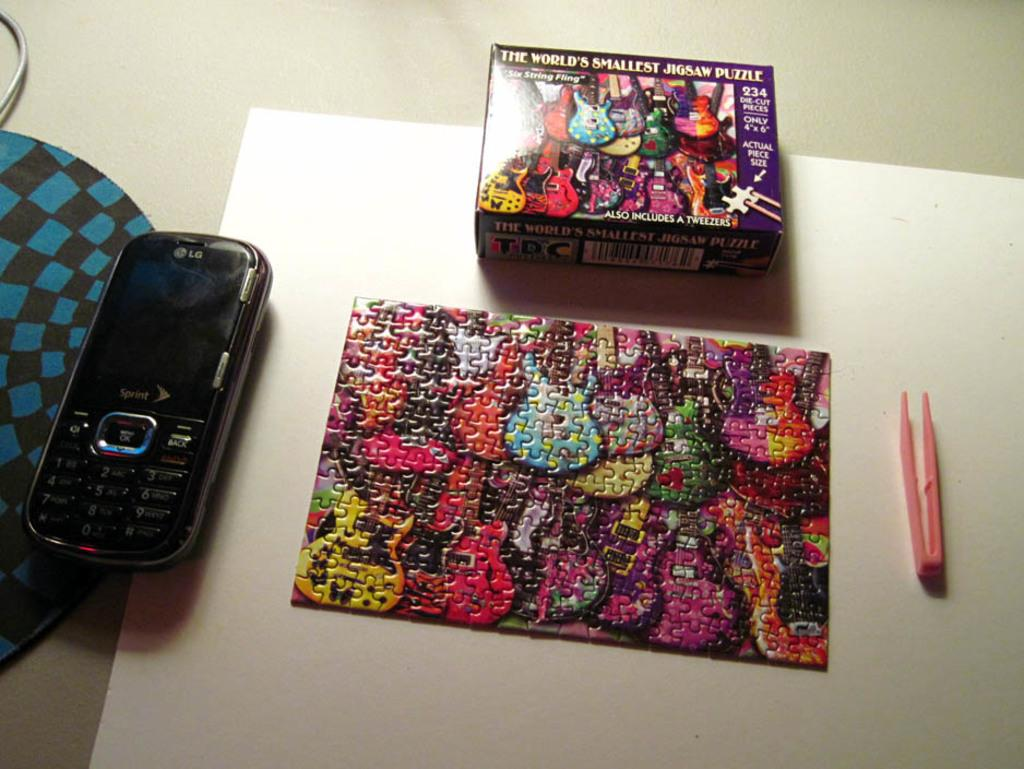<image>
Render a clear and concise summary of the photo. The world's smallest jigsaw puzzle has been completed and sits on a table. 